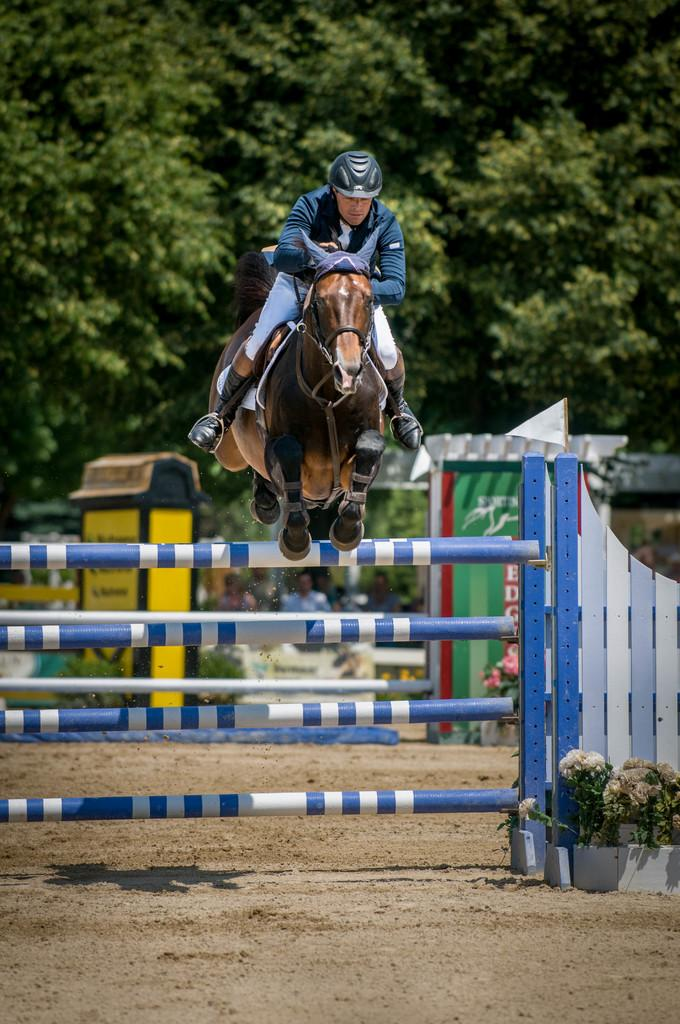What is the main action taking place in the image? There is a person riding a horse in the image, and the horse is jumping over a blue fence. What is the color of the fence that the horse is jumping over? The fence is blue. What can be seen behind the person riding the horse? There are objects behind the person. What type of natural scenery is visible in the background? There are plenty of trees in the background. Can you see any blood or wounds on the person riding the horse in the image? There is no indication of blood or wounds on the person riding the horse in the image. What type of harmony is being displayed by the person and the horse in the image? The image does not depict any specific type of harmony between the person and the horse; it simply shows them in the act of jumping over a fence. 